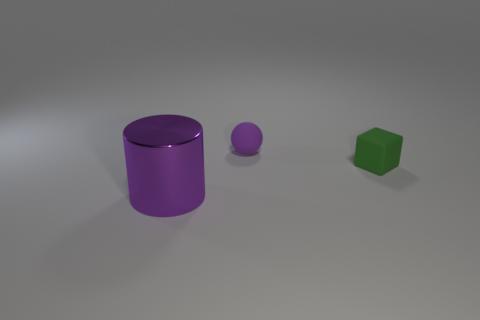What number of spheres are the same color as the block? 0 